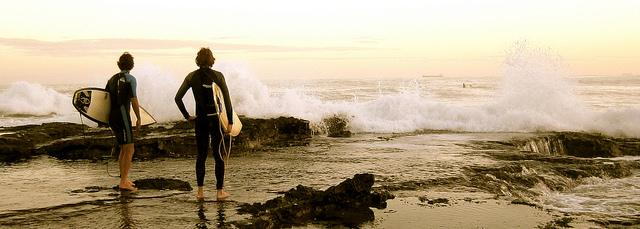Why are the surfer's hesitant to surf here? Please explain your reasoning. rocks. The surfers don't want to crash into the rocks. 